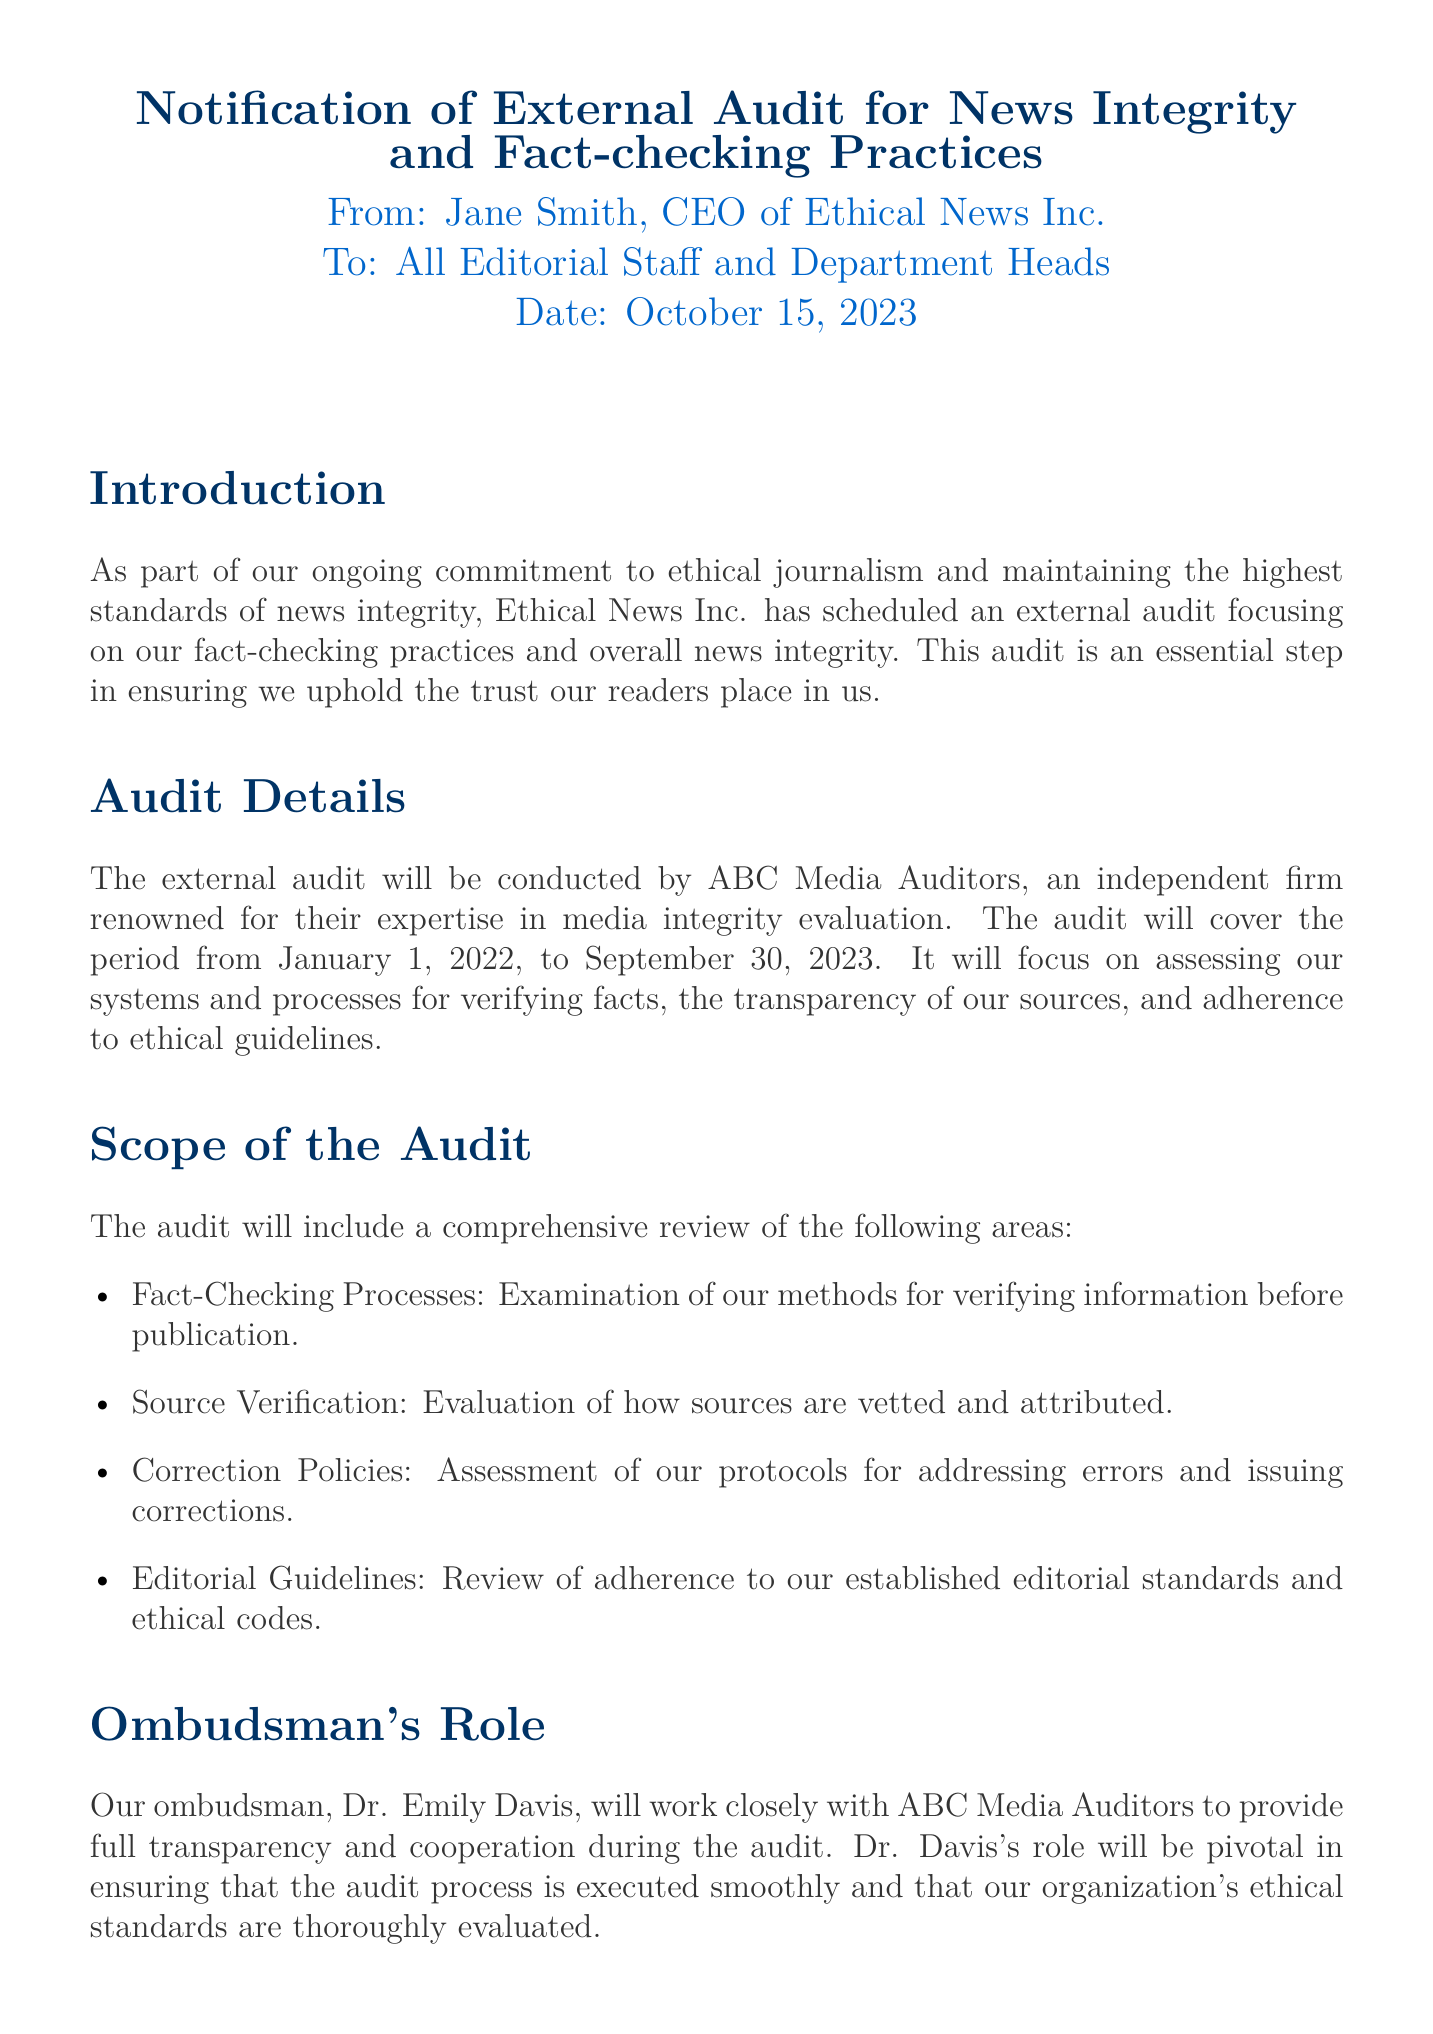What is the purpose of the external audit? The external audit aims to ensure the organization maintains high standards of news integrity and ethical journalism.
Answer: news integrity and ethical journalism Who will conduct the audit? The audit will be conducted by ABC Media Auditors, an independent firm.
Answer: ABC Media Auditors What is the period covered by the audit? The audit will cover the period from January 1, 2022, to September 30, 2023.
Answer: January 1, 2022, to September 30, 2023 When will the audit commence? The audit will commence on November 1, 2023.
Answer: November 1, 2023 Who is the ombudsman responsible for the audit? The ombudsman responsible for the audit is Dr. Emily Davis.
Answer: Dr. Emily Davis What is the deadline for the preliminary report? The preliminary report will be shared by December 20, 2023.
Answer: December 20, 2023 What areas will the audit review? The audit will review fact-checking processes, source verification, correction policies, and editorial guidelines.
Answer: fact-checking processes, source verification, correction policies, editorial guidelines What should departments be prepared to provide during the audit? Departments should be prepared to provide necessary documentation and facilitate interviews with the auditors.
Answer: necessary documentation and facilitate interviews What is the organization’s commitment related to news integrity? The organization is committed to upholding the trust readers place in them by ensuring news integrity.
Answer: upholding the trust readers place in them 